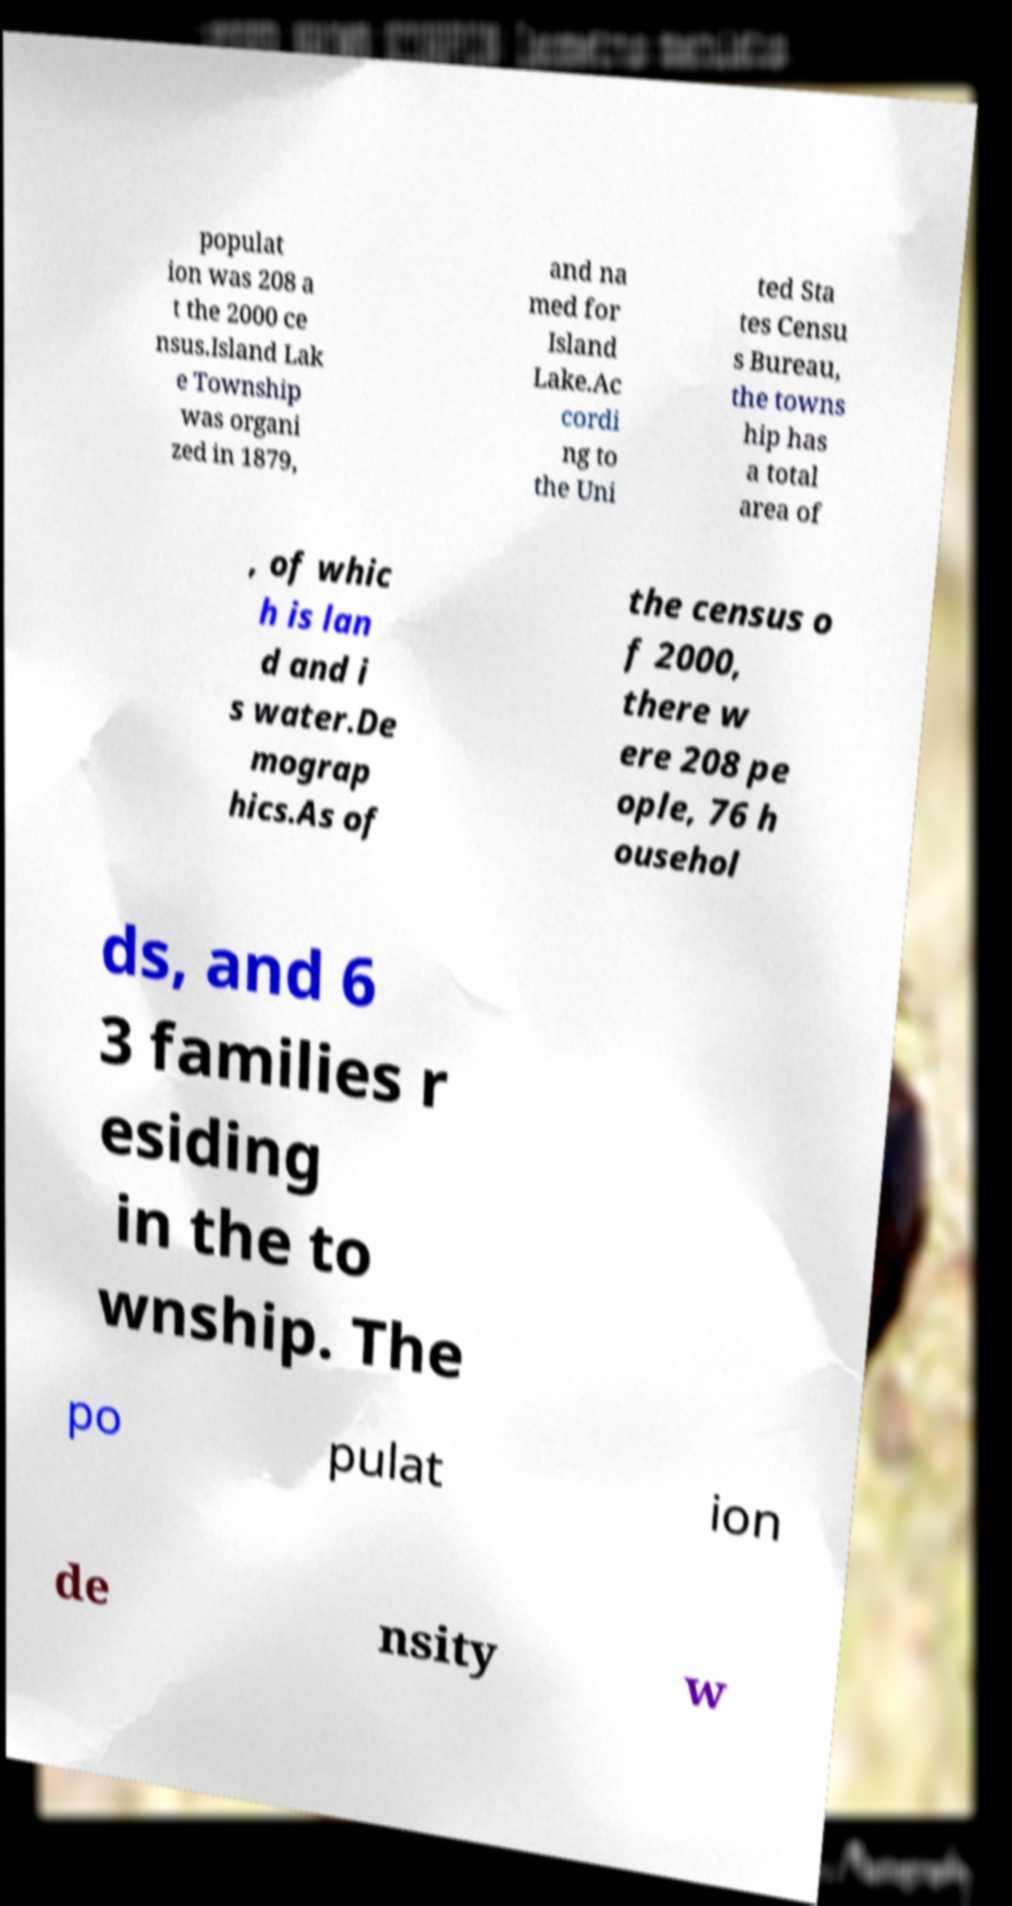Can you read and provide the text displayed in the image?This photo seems to have some interesting text. Can you extract and type it out for me? populat ion was 208 a t the 2000 ce nsus.Island Lak e Township was organi zed in 1879, and na med for Island Lake.Ac cordi ng to the Uni ted Sta tes Censu s Bureau, the towns hip has a total area of , of whic h is lan d and i s water.De mograp hics.As of the census o f 2000, there w ere 208 pe ople, 76 h ousehol ds, and 6 3 families r esiding in the to wnship. The po pulat ion de nsity w 